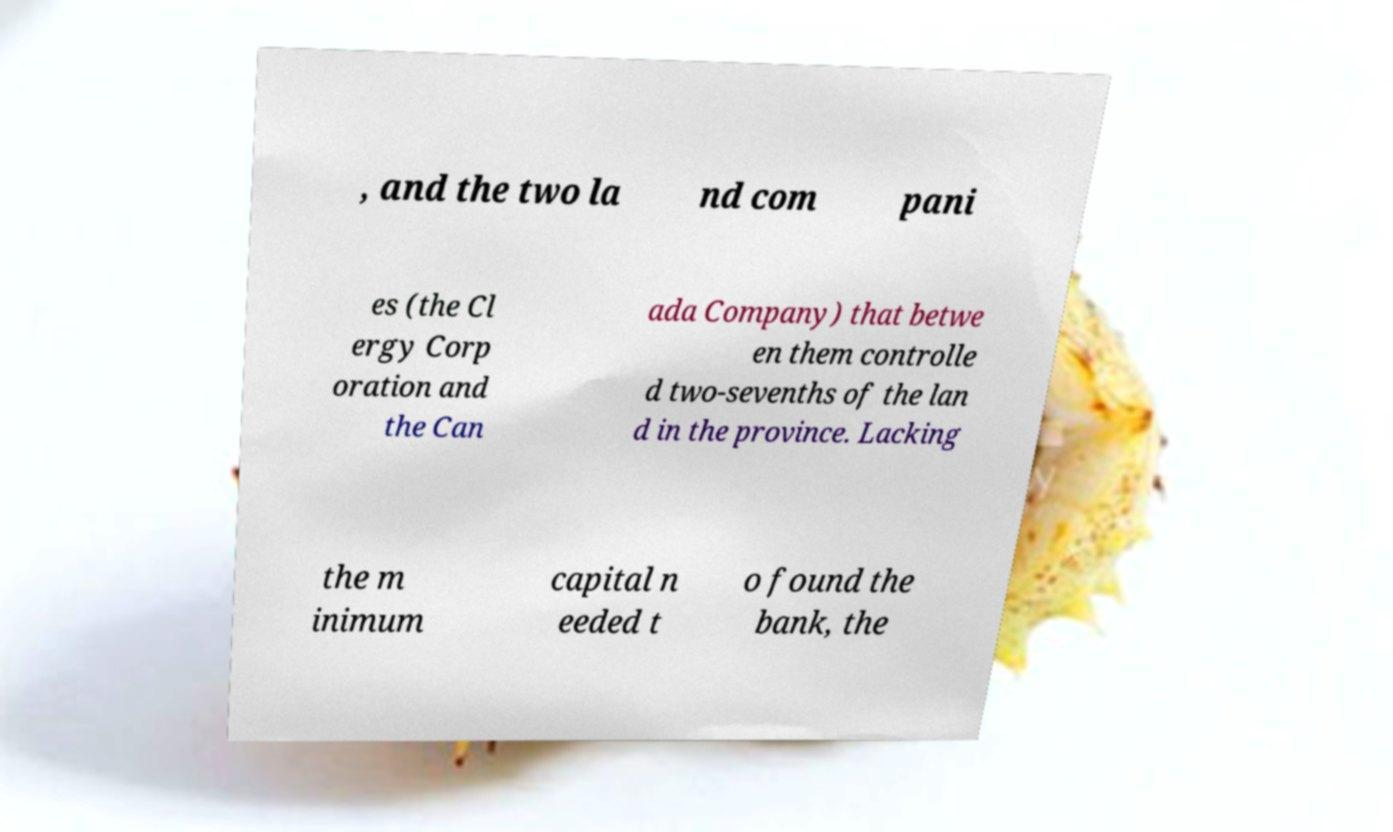What messages or text are displayed in this image? I need them in a readable, typed format. , and the two la nd com pani es (the Cl ergy Corp oration and the Can ada Company) that betwe en them controlle d two-sevenths of the lan d in the province. Lacking the m inimum capital n eeded t o found the bank, the 